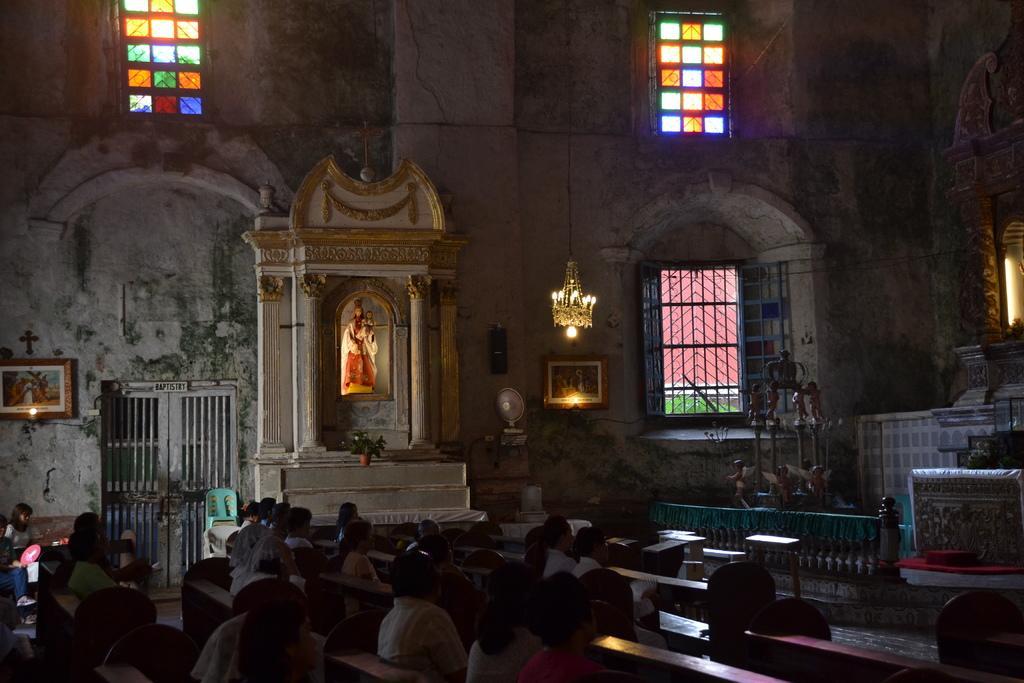Describe this image in one or two sentences. In this image we can see group of people sitting on benches. In the right side we can see group of statues placed on the ground. In the background we can see a chandelier ,statue on the wall ,plant ,photo frames on the wall and group of windows. 